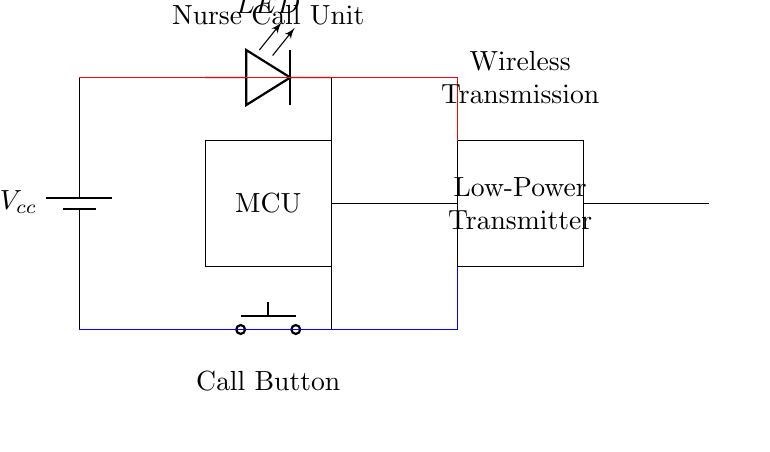What is the primary function of the call button? The call button's primary function is to initiate a call or signal to the nurse. This is indicated by its placement at the bottom of the circuit and its labeling.
Answer: Initiate a call What type of power source is used in this circuit? The circuit uses a battery as the power source, which is labeled as "Vcc" in the battery symbol.
Answer: Battery How many main components are visible in this circuit diagram? The circuit diagram shows four main components: the MCU, low-power transmitter, call button, and LED indicator.
Answer: Four What type of signal does the low-power transmitter send? The low-power transmitter sends a wireless signal, inferred from its label and its connection to the antenna.
Answer: Wireless signal Why is low power transmission significant for this nurse call system? Low power transmission is significant because it conserves battery life and is suitable for close-range communication, making it ideal for devices like nurse call systems. This reduces the need for frequent battery replacements and enhances the sustainability of the system.
Answer: Conserves battery life What does the LED indicator signify in this circuit? The LED indicator signifies the status of the signal or the system, typically showing whether the call is active or not. Its position at the top of the diagram suggests it provides visual feedback.
Answer: Status of the call 